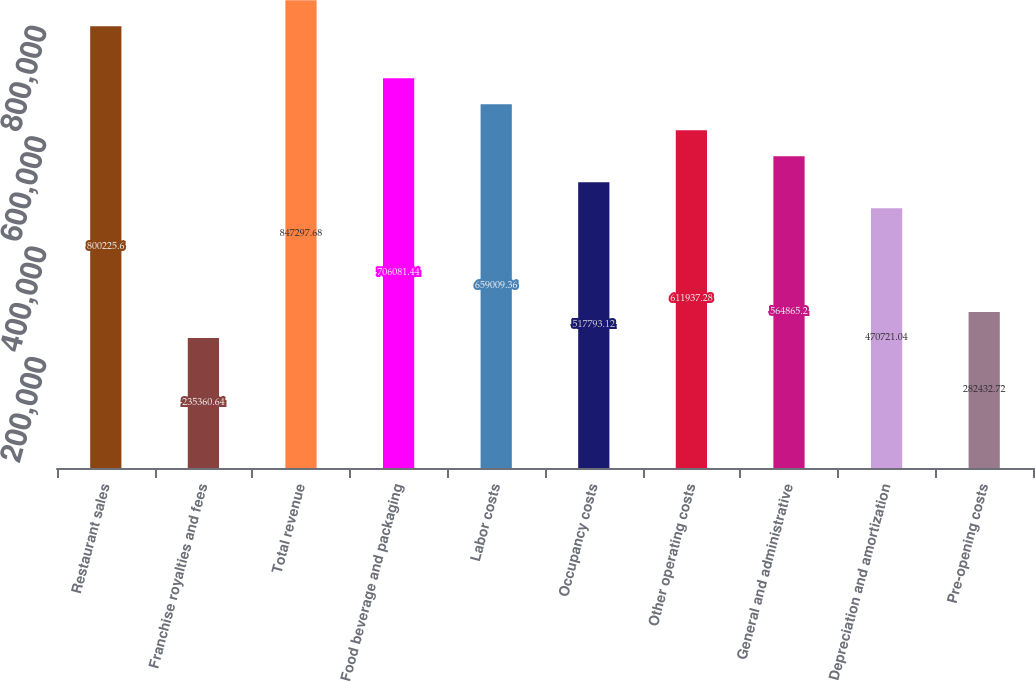Convert chart. <chart><loc_0><loc_0><loc_500><loc_500><bar_chart><fcel>Restaurant sales<fcel>Franchise royalties and fees<fcel>Total revenue<fcel>Food beverage and packaging<fcel>Labor costs<fcel>Occupancy costs<fcel>Other operating costs<fcel>General and administrative<fcel>Depreciation and amortization<fcel>Pre-opening costs<nl><fcel>800226<fcel>235361<fcel>847298<fcel>706081<fcel>659009<fcel>517793<fcel>611937<fcel>564865<fcel>470721<fcel>282433<nl></chart> 